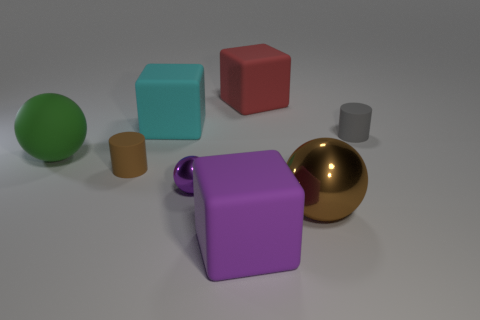What number of other large balls have the same color as the large metal sphere?
Offer a terse response. 0. What is the size of the brown rubber cylinder?
Your answer should be very brief. Small. Does the brown cylinder have the same size as the cyan block?
Provide a succinct answer. No. What color is the ball that is behind the large metallic ball and in front of the small brown object?
Ensure brevity in your answer.  Purple. How many large things are made of the same material as the small brown object?
Provide a succinct answer. 4. What number of tiny purple shiny things are there?
Keep it short and to the point. 1. There is a red rubber block; is its size the same as the block in front of the green rubber sphere?
Your response must be concise. Yes. What material is the cylinder that is right of the small brown cylinder that is in front of the large green rubber ball made of?
Ensure brevity in your answer.  Rubber. There is a gray matte cylinder behind the tiny matte cylinder to the left of the matte cylinder to the right of the purple metal ball; what is its size?
Provide a succinct answer. Small. There is a small gray thing; is its shape the same as the brown object on the right side of the red block?
Your response must be concise. No. 